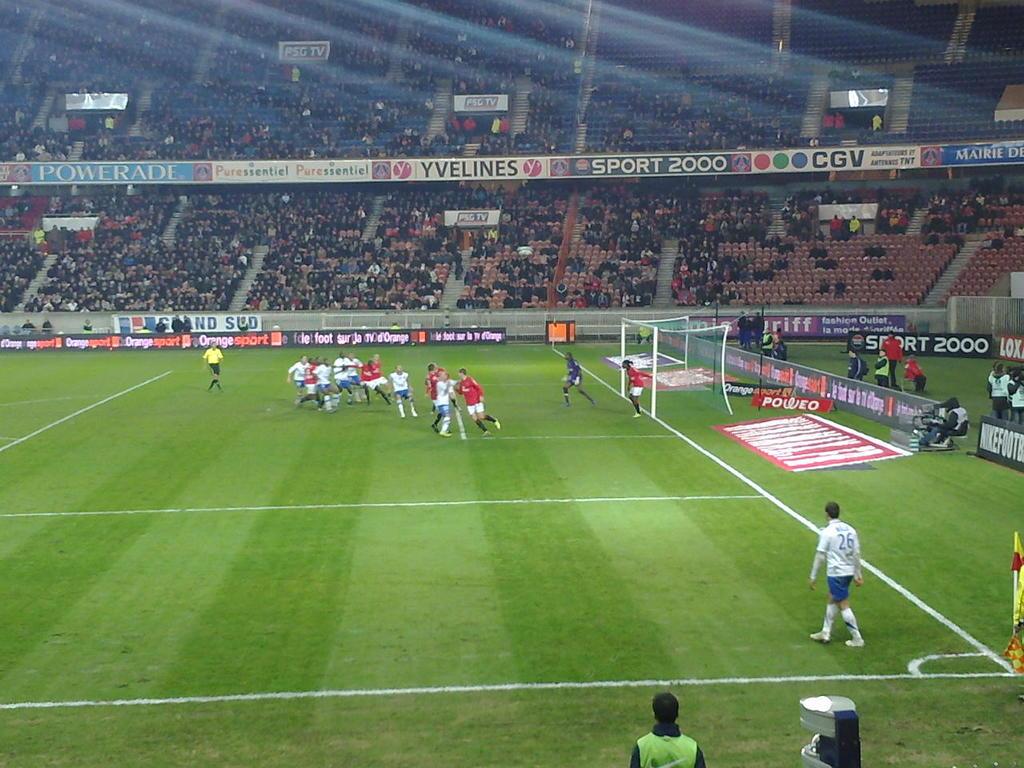What beverage is being advertised on the left side?
Provide a short and direct response. Powerade. What is the number of the sport sponsor?
Provide a succinct answer. 2000. 